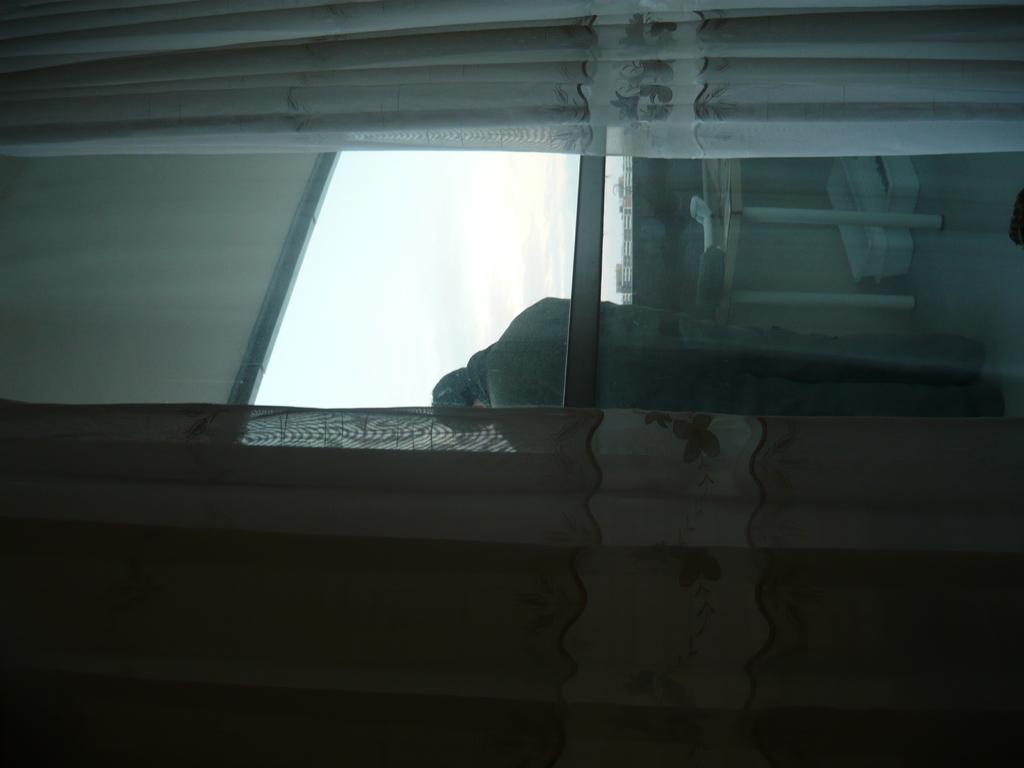Please provide a concise description of this image. In this image there is one person standing in middle of this image and there is a curtain at left side of this image and right side of this image as well and there is a glass door in middle of this image , and as we can see there is a sky in the background. 